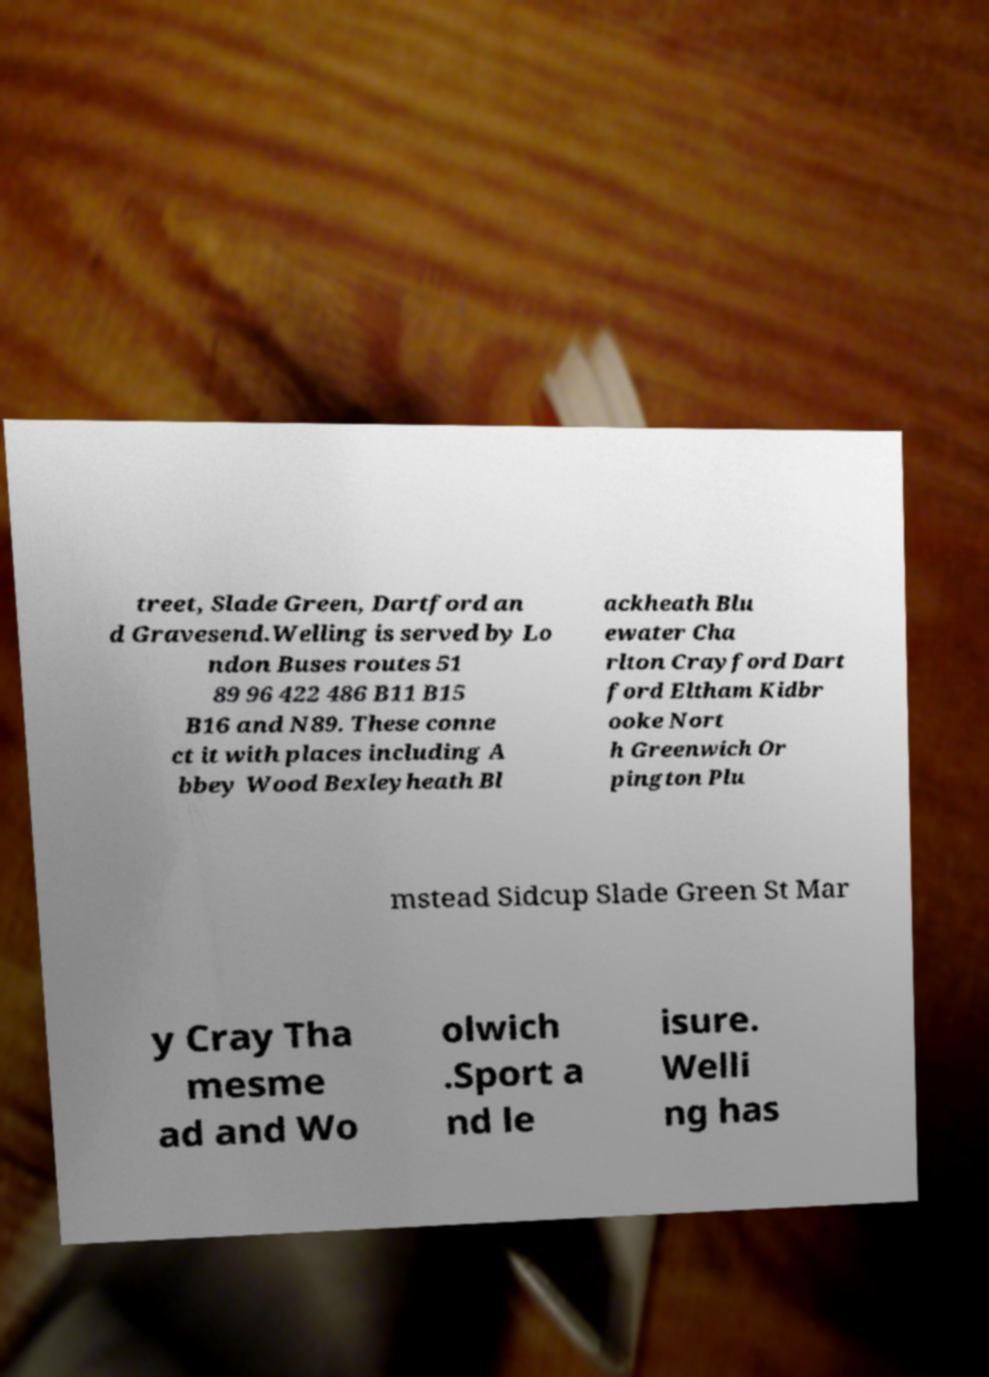There's text embedded in this image that I need extracted. Can you transcribe it verbatim? treet, Slade Green, Dartford an d Gravesend.Welling is served by Lo ndon Buses routes 51 89 96 422 486 B11 B15 B16 and N89. These conne ct it with places including A bbey Wood Bexleyheath Bl ackheath Blu ewater Cha rlton Crayford Dart ford Eltham Kidbr ooke Nort h Greenwich Or pington Plu mstead Sidcup Slade Green St Mar y Cray Tha mesme ad and Wo olwich .Sport a nd le isure. Welli ng has 